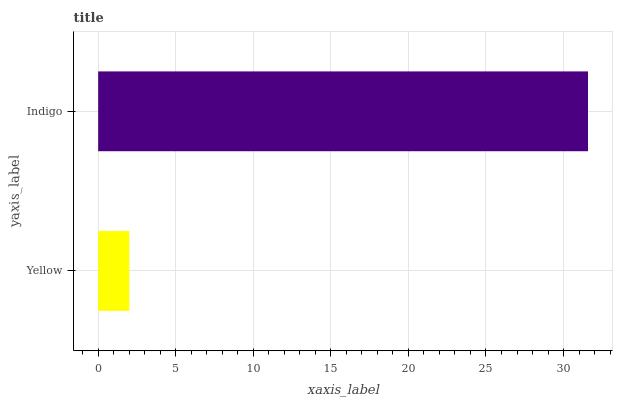Is Yellow the minimum?
Answer yes or no. Yes. Is Indigo the maximum?
Answer yes or no. Yes. Is Indigo the minimum?
Answer yes or no. No. Is Indigo greater than Yellow?
Answer yes or no. Yes. Is Yellow less than Indigo?
Answer yes or no. Yes. Is Yellow greater than Indigo?
Answer yes or no. No. Is Indigo less than Yellow?
Answer yes or no. No. Is Indigo the high median?
Answer yes or no. Yes. Is Yellow the low median?
Answer yes or no. Yes. Is Yellow the high median?
Answer yes or no. No. Is Indigo the low median?
Answer yes or no. No. 